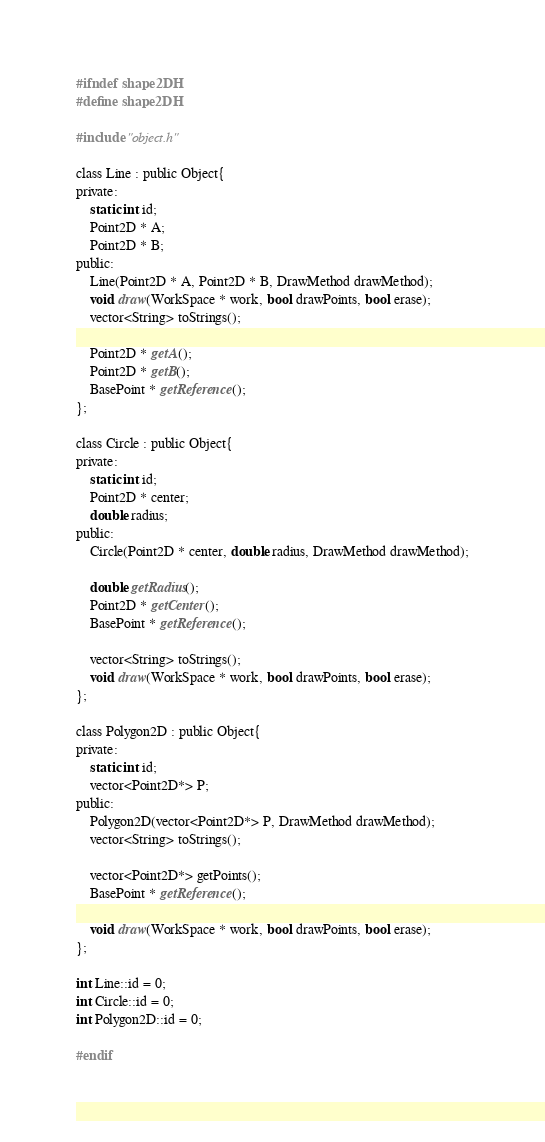<code> <loc_0><loc_0><loc_500><loc_500><_C_>#ifndef shape2DH
#define shape2DH

#include "object.h"

class Line : public Object{
private:
	static int id;
	Point2D * A;
	Point2D * B;
public:
	Line(Point2D * A, Point2D * B, DrawMethod drawMethod);
	void draw(WorkSpace * work, bool drawPoints, bool erase);
	vector<String> toStrings();

	Point2D * getA();
	Point2D * getB();
	BasePoint * getReference();
};

class Circle : public Object{
private:
	static int id;
	Point2D * center;
	double radius;
public:
	Circle(Point2D * center, double radius, DrawMethod drawMethod);

	double getRadius();
    Point2D * getCenter();
	BasePoint * getReference();

	vector<String> toStrings();
	void draw(WorkSpace * work, bool drawPoints, bool erase);
};

class Polygon2D : public Object{
private:
	static int id;
	vector<Point2D*> P;
public:
	Polygon2D(vector<Point2D*> P, DrawMethod drawMethod);
	vector<String> toStrings();
	
	vector<Point2D*> getPoints();
	BasePoint * getReference();

	void draw(WorkSpace * work, bool drawPoints, bool erase);
};

int Line::id = 0;
int Circle::id = 0;
int Polygon2D::id = 0;

#endif</code> 